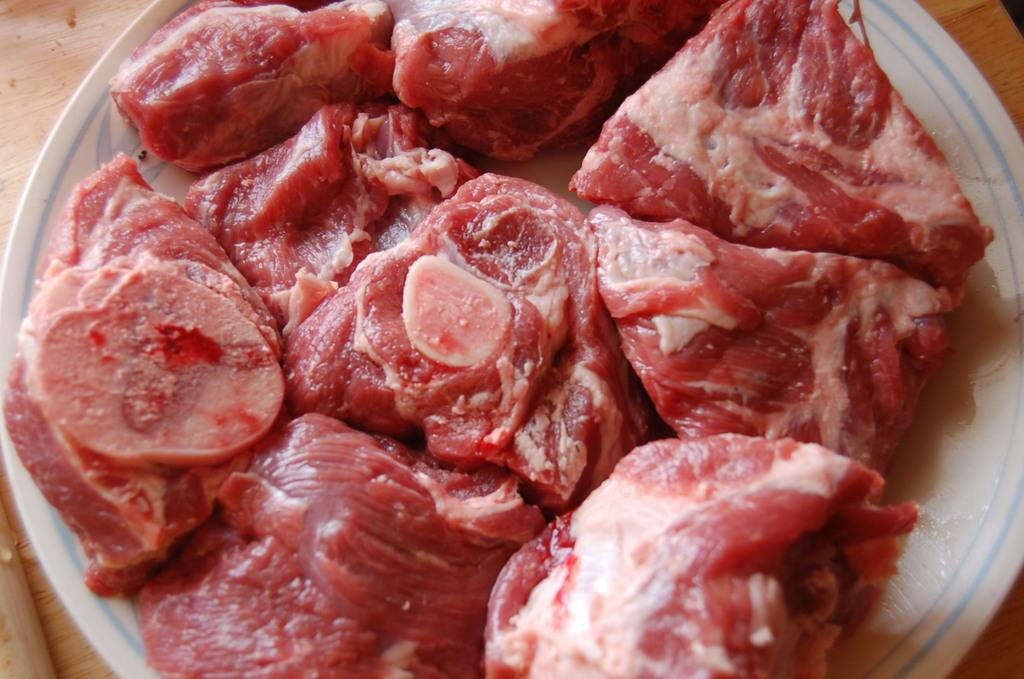What type of food can be seen in the image? There is meat in the image. How is the meat stored or contained? The meat is in a container. Where is the container with the meat located? The container is placed on a surface. What type of house is visible in the image? There is no house present in the image; it only features meat in a container placed on a surface. How does the meat feel about the situation in the image? The meat is an inanimate object and does not have feelings or a temper. 